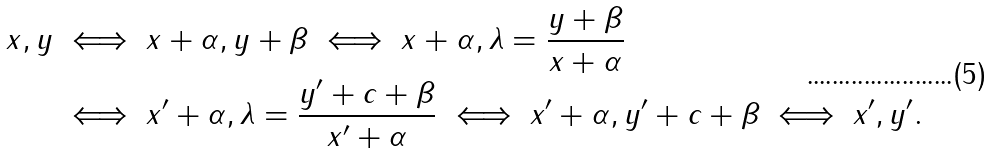Convert formula to latex. <formula><loc_0><loc_0><loc_500><loc_500>x , y & \iff x + \alpha , y + \beta \iff x + \alpha , \lambda = \frac { y + \beta } { x + \alpha } \\ & \iff x ^ { \prime } + \alpha , \lambda = \frac { y ^ { \prime } + c + \beta } { x ^ { \prime } + \alpha } \iff x ^ { \prime } + \alpha , y ^ { \prime } + c + \beta \iff x ^ { \prime } , y ^ { \prime } .</formula> 